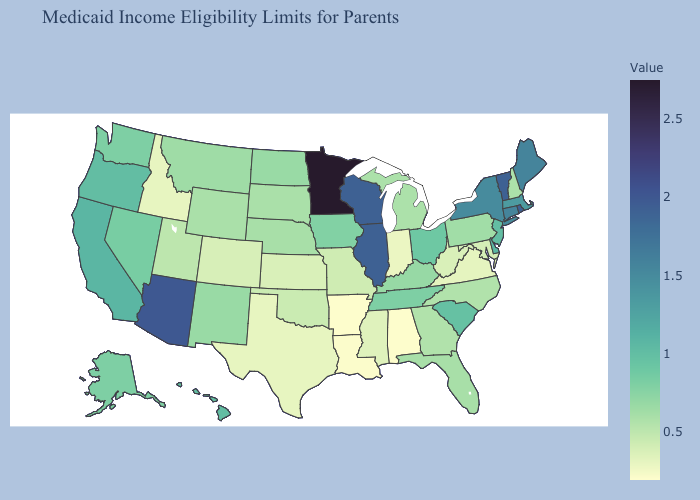Among the states that border Wisconsin , does Iowa have the lowest value?
Concise answer only. No. Does New Hampshire have the lowest value in the Northeast?
Short answer required. Yes. Does Georgia have the highest value in the USA?
Write a very short answer. No. Does Alaska have the lowest value in the West?
Write a very short answer. No. Does Arizona have the lowest value in the West?
Answer briefly. No. Does Illinois have the highest value in the MidWest?
Quick response, please. No. 